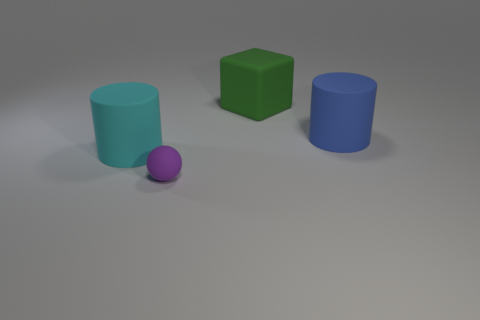There is a blue object that is the same shape as the cyan matte object; what is its size?
Keep it short and to the point. Large. There is a big blue cylinder; are there any things behind it?
Your answer should be compact. Yes. Is the shape of the blue rubber thing the same as the rubber thing on the left side of the small purple sphere?
Ensure brevity in your answer.  Yes. There is a block that is the same material as the purple sphere; what is its color?
Make the answer very short. Green. The big rubber cube has what color?
Offer a very short reply. Green. How many things are both on the right side of the cyan cylinder and behind the purple matte thing?
Keep it short and to the point. 2. The blue object that is the same size as the cyan rubber thing is what shape?
Offer a very short reply. Cylinder. There is a big cylinder that is on the right side of the big cylinder that is in front of the large blue object; is there a tiny purple thing that is to the left of it?
Provide a short and direct response. Yes. There is a small rubber object; does it have the same color as the rubber cylinder on the right side of the big cyan matte cylinder?
Your response must be concise. No. There is a rubber thing in front of the big matte object that is left of the small ball; what size is it?
Your response must be concise. Small. 